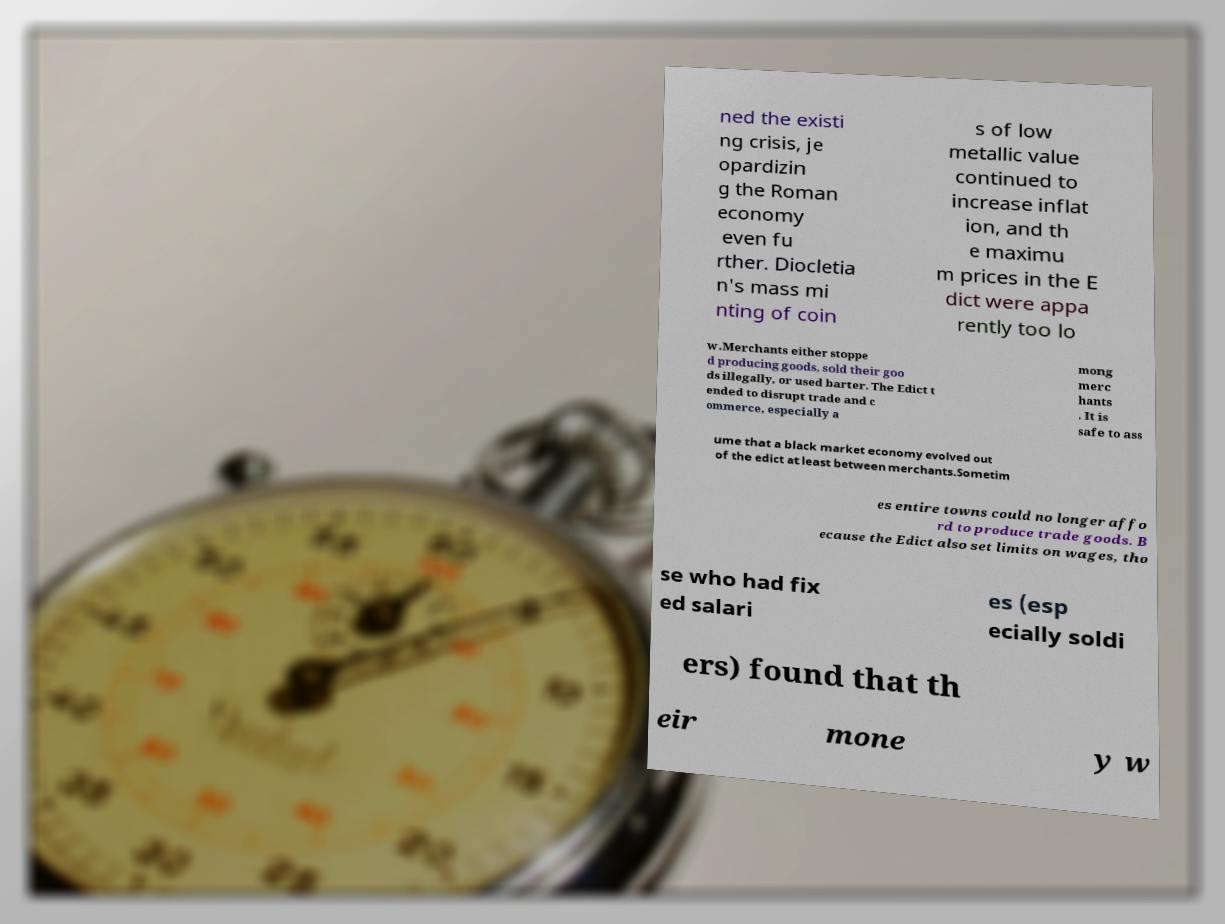There's text embedded in this image that I need extracted. Can you transcribe it verbatim? ned the existi ng crisis, je opardizin g the Roman economy even fu rther. Diocletia n's mass mi nting of coin s of low metallic value continued to increase inflat ion, and th e maximu m prices in the E dict were appa rently too lo w.Merchants either stoppe d producing goods, sold their goo ds illegally, or used barter. The Edict t ended to disrupt trade and c ommerce, especially a mong merc hants . It is safe to ass ume that a black market economy evolved out of the edict at least between merchants.Sometim es entire towns could no longer affo rd to produce trade goods. B ecause the Edict also set limits on wages, tho se who had fix ed salari es (esp ecially soldi ers) found that th eir mone y w 